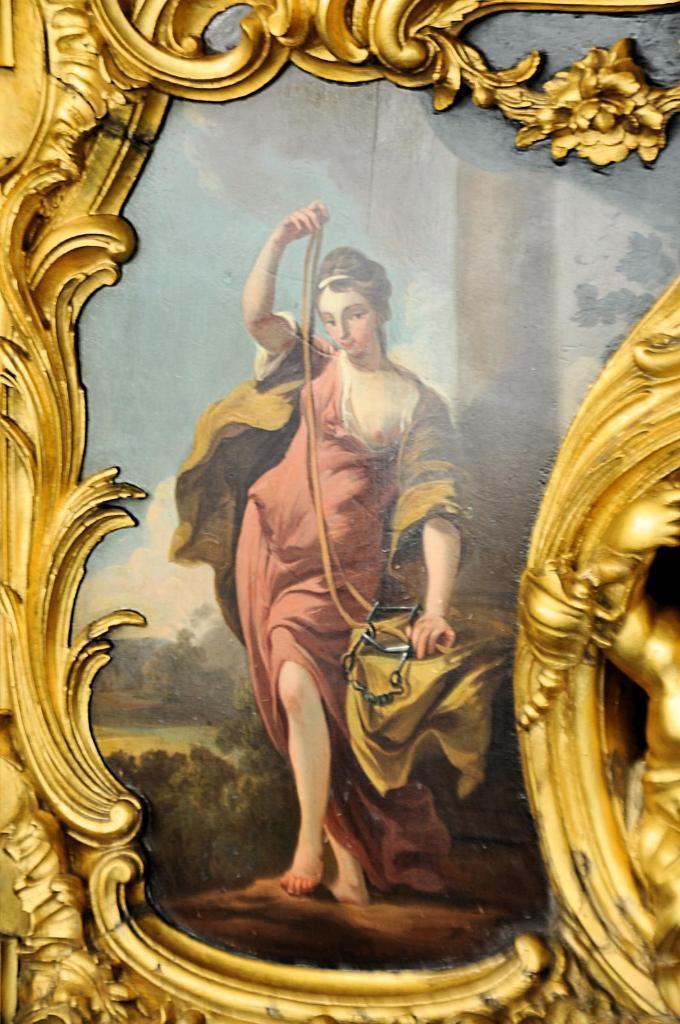Describe this image in one or two sentences. In this picture I can observe a photo frame which is in gold color. In this frame there is a woman wearing brown color dress. 